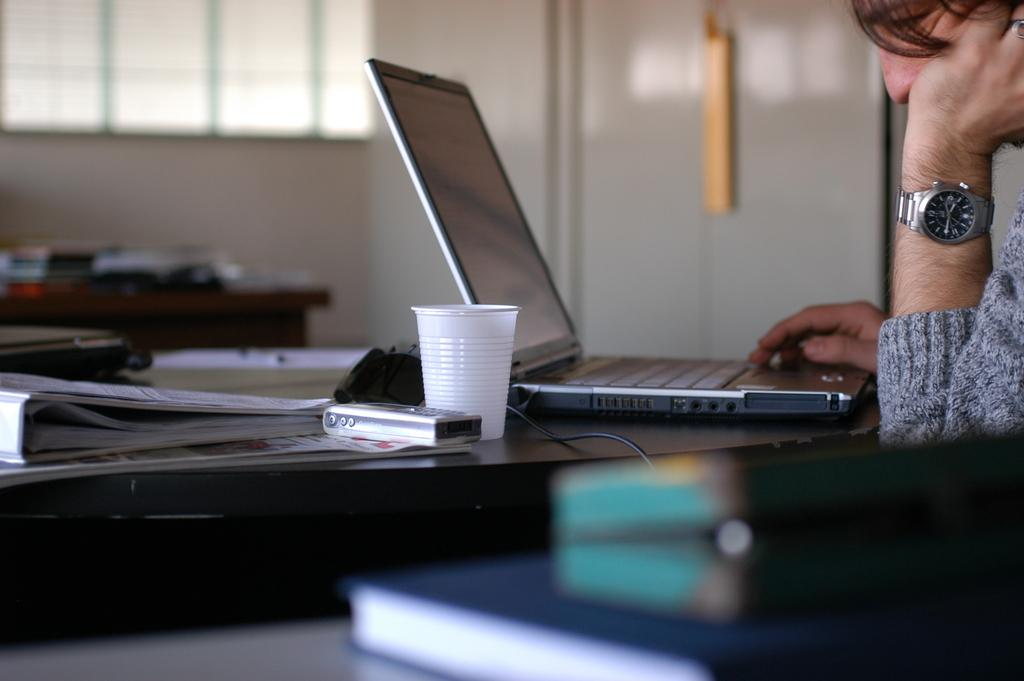What is the person in the image doing? The person is sitting in the image. What object is the person using or interacting with? The person is in front of a laptop. Where is the laptop placed? The laptop is on a table. What other objects are on the table? There is a glass and a mobile phone on the table. What type of jail can be seen in the image? There is no jail present in the image. What kind of shock is the person experiencing in the image? There is no indication of any shock or surprise in the image. 